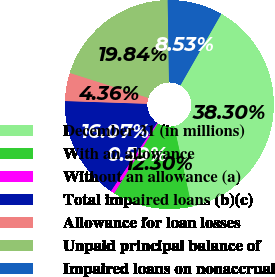<chart> <loc_0><loc_0><loc_500><loc_500><pie_chart><fcel>December 31 (in millions)<fcel>With an allowance<fcel>Without an allowance (a)<fcel>Total impaired loans (b)(c)<fcel>Allowance for loan losses<fcel>Unpaid principal balance of<fcel>Impaired loans on nonaccrual<nl><fcel>38.29%<fcel>12.3%<fcel>0.59%<fcel>16.07%<fcel>4.36%<fcel>19.84%<fcel>8.53%<nl></chart> 